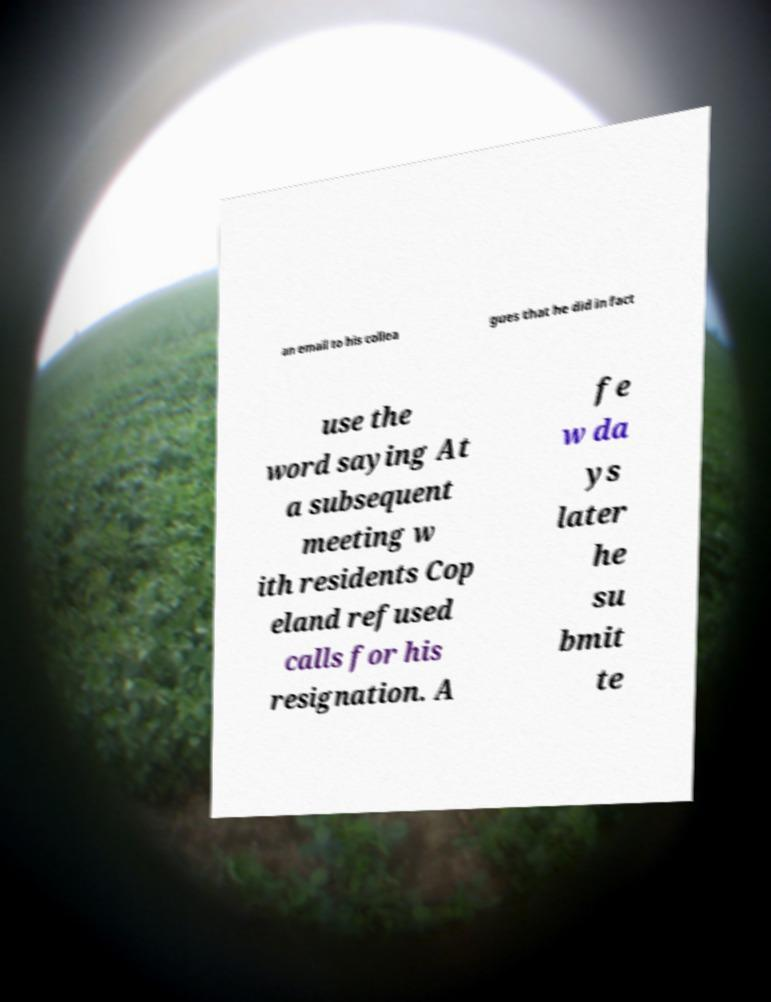Please identify and transcribe the text found in this image. an email to his collea gues that he did in fact use the word saying At a subsequent meeting w ith residents Cop eland refused calls for his resignation. A fe w da ys later he su bmit te 